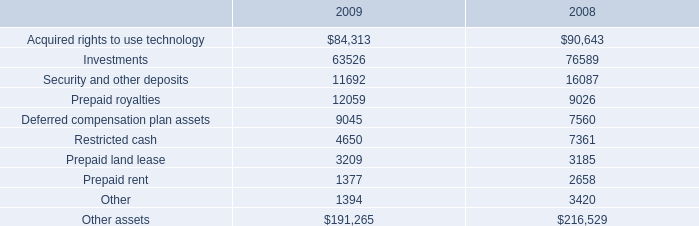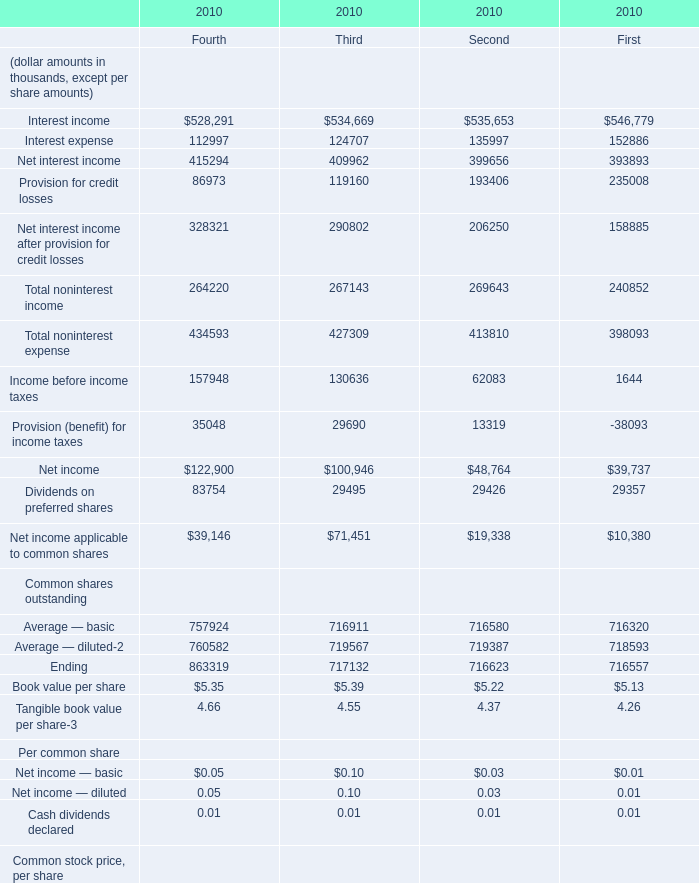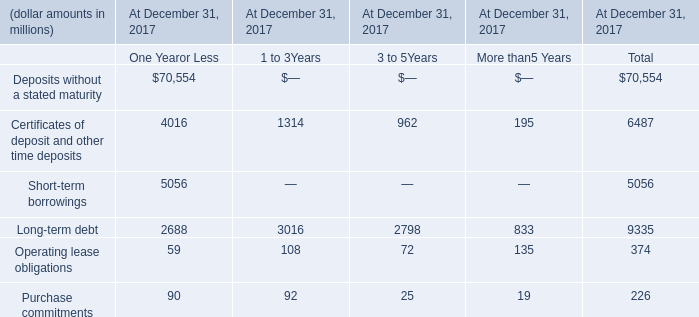What is the average amount of Deferred compensation plan assets of 2009, and Provision for credit losses of 2010 Second ? 
Computations: ((9045.0 + 193406.0) / 2)
Answer: 101225.5. 